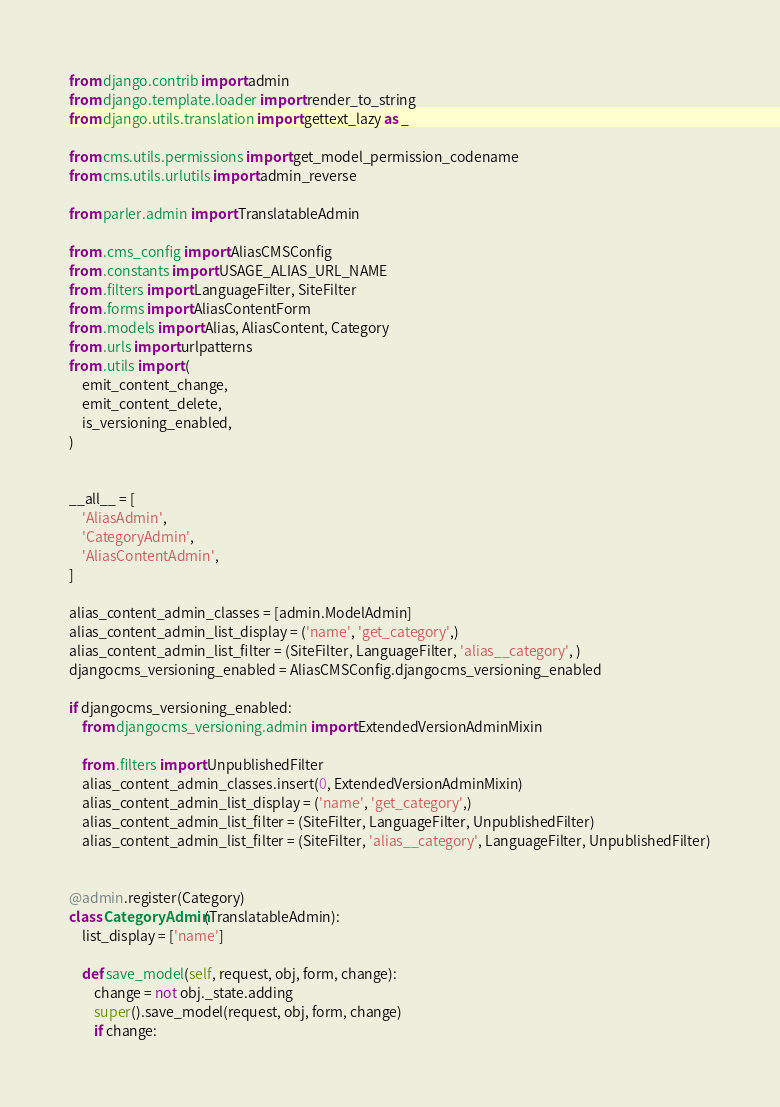<code> <loc_0><loc_0><loc_500><loc_500><_Python_>from django.contrib import admin
from django.template.loader import render_to_string
from django.utils.translation import gettext_lazy as _

from cms.utils.permissions import get_model_permission_codename
from cms.utils.urlutils import admin_reverse

from parler.admin import TranslatableAdmin

from .cms_config import AliasCMSConfig
from .constants import USAGE_ALIAS_URL_NAME
from .filters import LanguageFilter, SiteFilter
from .forms import AliasContentForm
from .models import Alias, AliasContent, Category
from .urls import urlpatterns
from .utils import (
    emit_content_change,
    emit_content_delete,
    is_versioning_enabled,
)


__all__ = [
    'AliasAdmin',
    'CategoryAdmin',
    'AliasContentAdmin',
]

alias_content_admin_classes = [admin.ModelAdmin]
alias_content_admin_list_display = ('name', 'get_category',)
alias_content_admin_list_filter = (SiteFilter, LanguageFilter, 'alias__category', )
djangocms_versioning_enabled = AliasCMSConfig.djangocms_versioning_enabled

if djangocms_versioning_enabled:
    from djangocms_versioning.admin import ExtendedVersionAdminMixin

    from .filters import UnpublishedFilter
    alias_content_admin_classes.insert(0, ExtendedVersionAdminMixin)
    alias_content_admin_list_display = ('name', 'get_category',)
    alias_content_admin_list_filter = (SiteFilter, LanguageFilter, UnpublishedFilter)
    alias_content_admin_list_filter = (SiteFilter, 'alias__category', LanguageFilter, UnpublishedFilter)


@admin.register(Category)
class CategoryAdmin(TranslatableAdmin):
    list_display = ['name']

    def save_model(self, request, obj, form, change):
        change = not obj._state.adding
        super().save_model(request, obj, form, change)
        if change:</code> 